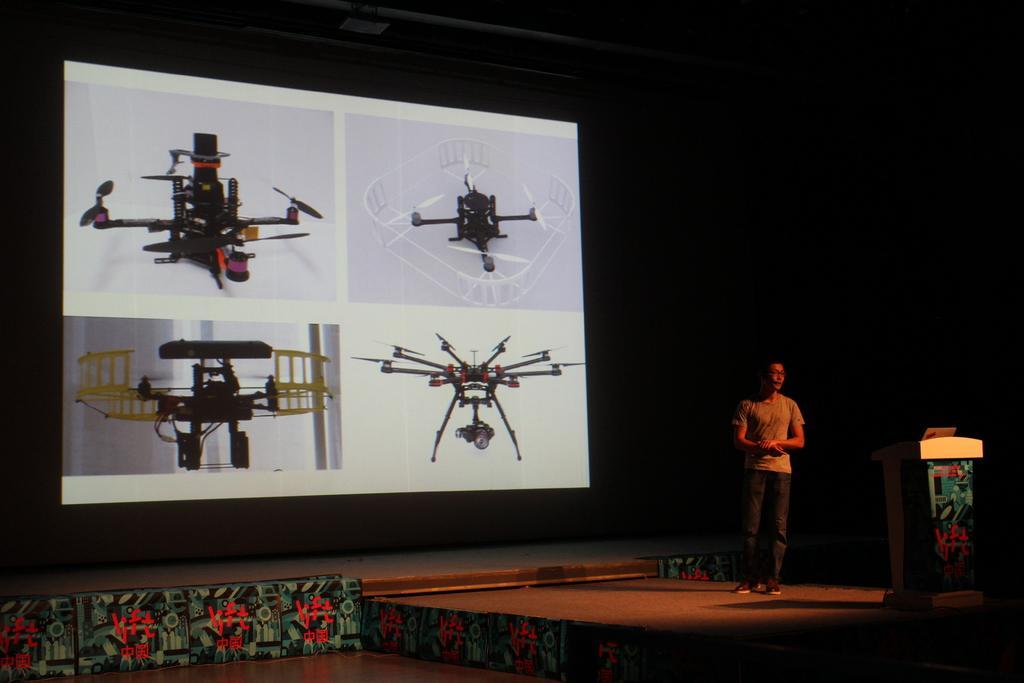How would you summarize this image in a sentence or two? A person is standing on a stage. On this podium there is a mic. Here we can see a screen. On this screen there are pictures of machines. 